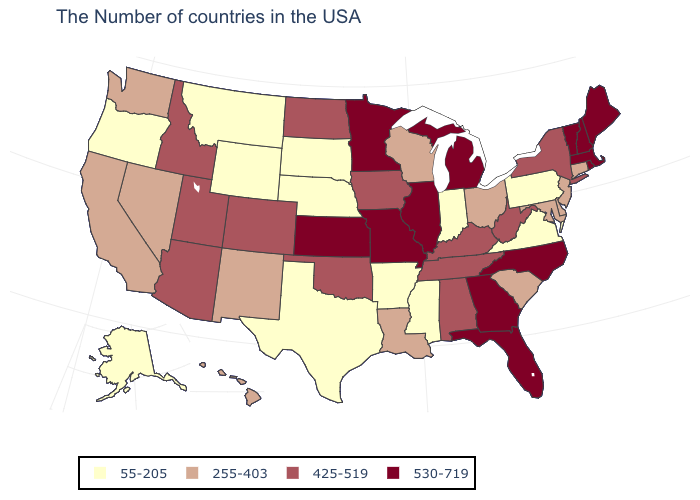Does the map have missing data?
Keep it brief. No. How many symbols are there in the legend?
Quick response, please. 4. Does the map have missing data?
Write a very short answer. No. Is the legend a continuous bar?
Keep it brief. No. What is the lowest value in states that border Wyoming?
Short answer required. 55-205. Which states hav the highest value in the Northeast?
Quick response, please. Maine, Massachusetts, Rhode Island, New Hampshire, Vermont. What is the highest value in states that border Virginia?
Short answer required. 530-719. What is the value of South Dakota?
Write a very short answer. 55-205. Which states have the highest value in the USA?
Answer briefly. Maine, Massachusetts, Rhode Island, New Hampshire, Vermont, North Carolina, Florida, Georgia, Michigan, Illinois, Missouri, Minnesota, Kansas. Does Georgia have a higher value than Michigan?
Short answer required. No. Name the states that have a value in the range 425-519?
Keep it brief. New York, West Virginia, Kentucky, Alabama, Tennessee, Iowa, Oklahoma, North Dakota, Colorado, Utah, Arizona, Idaho. What is the highest value in the USA?
Write a very short answer. 530-719. Name the states that have a value in the range 55-205?
Quick response, please. Pennsylvania, Virginia, Indiana, Mississippi, Arkansas, Nebraska, Texas, South Dakota, Wyoming, Montana, Oregon, Alaska. What is the value of Georgia?
Give a very brief answer. 530-719. What is the lowest value in states that border Tennessee?
Write a very short answer. 55-205. 